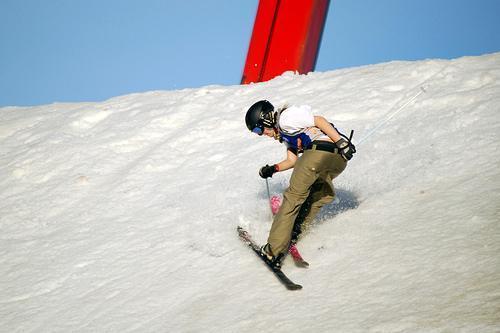How many people are present?
Give a very brief answer. 1. How many poles are there?
Give a very brief answer. 1. 